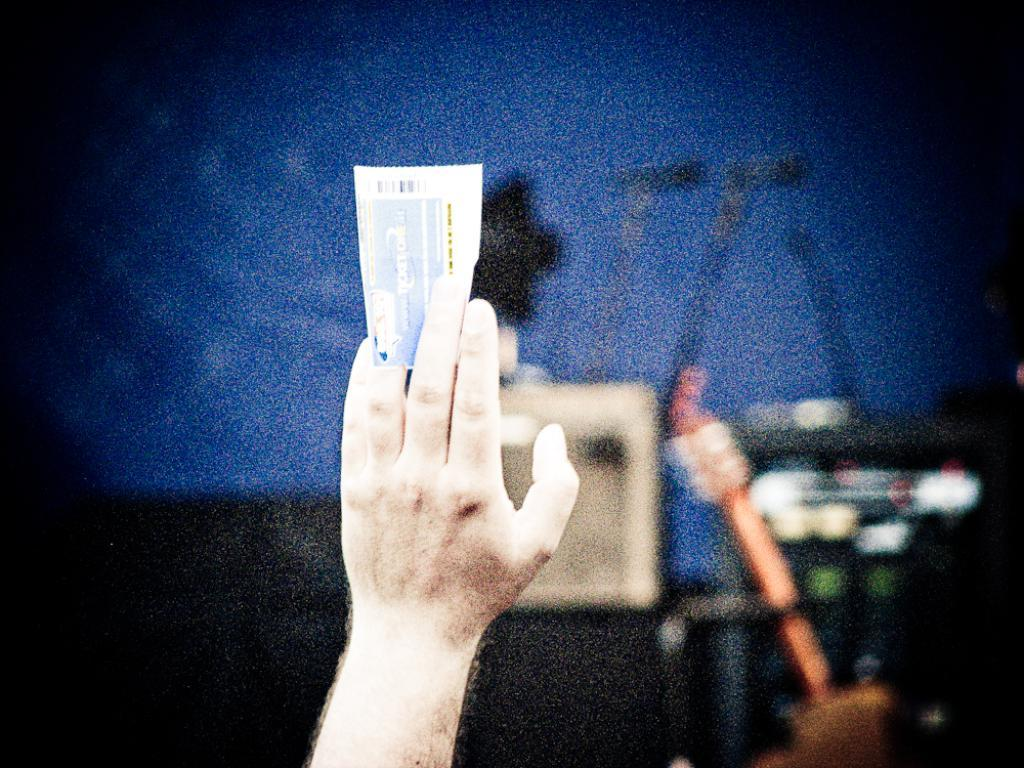What is the person holding in the image? There is a hand holding a paper in the image. Can you describe the background of the image? The background of the image is blurred. What type of plastic object is visible on the page in the image? There is no plastic object present on the page in the image, as the only visible object is the paper being held by the hand. Is there a judge in the image? There is no mention of a judge or any person in the image, only a hand holding a paper. 